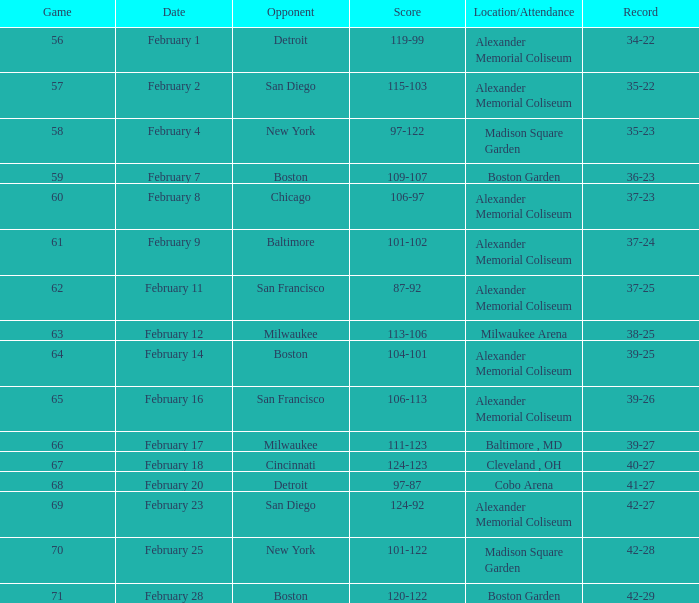What is the game number with a score of 87-92? 62.0. 